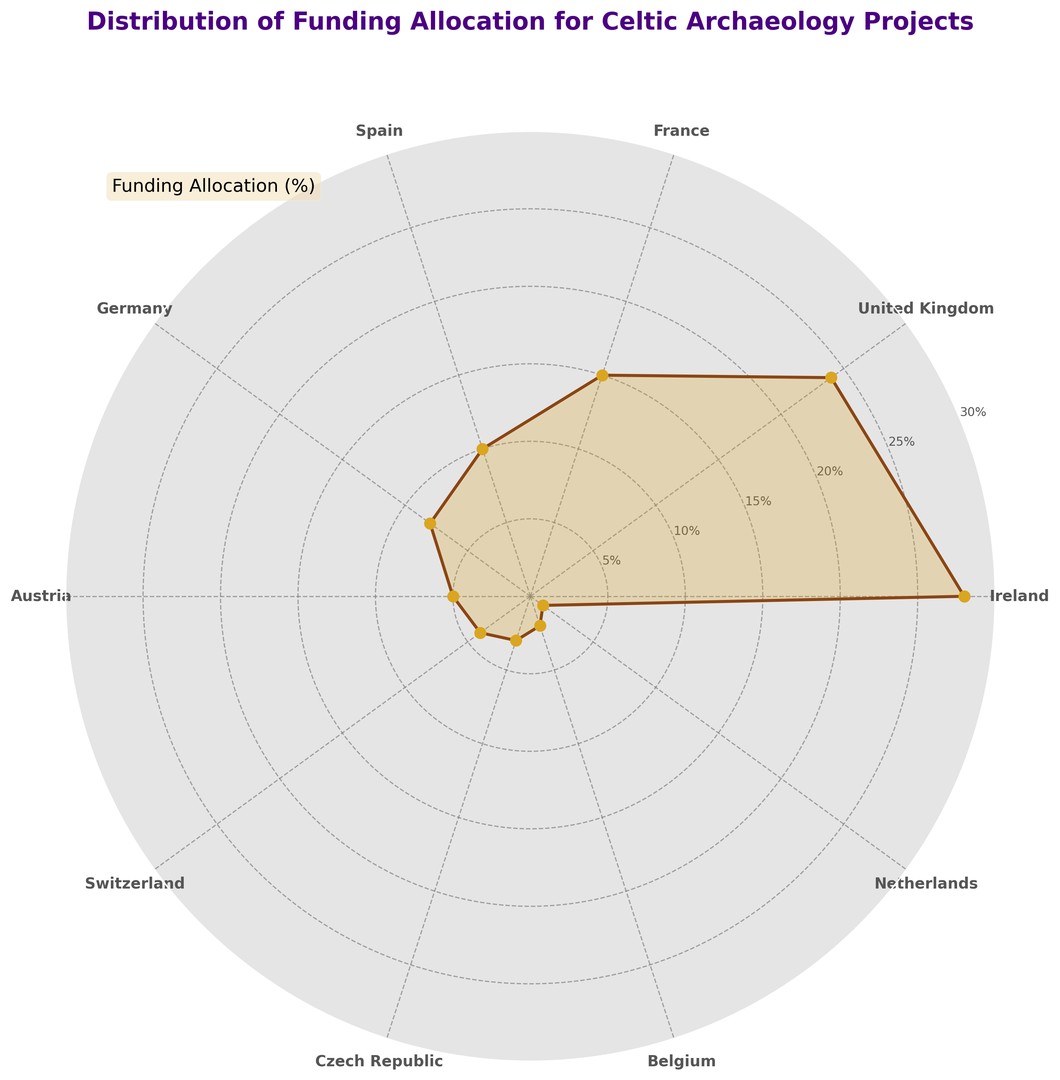What is the funding percentage for the United Kingdom? Identify the segment labeled 'United Kingdom' on the rose chart and read the associated funding percentage.
Answer: 24% Which country has the highest funding allocation? Observe which segment has the greatest extent from the center of the chart. The segment for 'Ireland' reaches the outermost point, indicating the highest funding allocation.
Answer: Ireland Which two countries combined account for more than half of the total funding allocation? Calculate the combined funding of the top countries. Ireland accounts for 28%, and the United Kingdom accounts for 24%, totaling 52%, which is more than half.
Answer: Ireland and United Kingdom Rank the top three countries by funding allocation. Identify the three largest segments in the rose chart by their extent. The segments belong to Ireland (28%), United Kingdom (24%), and France (15%).
Answer: Ireland, United Kingdom, France What is the difference in funding allocation between Spain and Germany? Observe the segments for Spain (10%) and Germany (8%), then calculate the difference: 10% - 8% = 2%.
Answer: 2% How many countries have a funding allocation of less than 5%? Identify the segments less than 5%. These are for Switzerland (4%), Czech Republic (3%), Belgium (2%), and Netherlands (1%). There are 4 such countries.
Answer: 4 Which country has the smallest funding allocation? Observe the segment with the smallest extent from the center. The segment for 'Netherlands' has the smallest extent, indicating 1%.
Answer: Netherlands Is total funding for Germany and Austria greater than for France? Add the segments for Germany (8%) and Austria (5%) yielding 13%. Compare it to France's 15%. Since 13% < 15%, it is not greater.
Answer: No What is the total funding percentage for all countries in the rose chart? The sum of all funding percentages: 28 + 24 + 15 + 10 + 8 + 5 + 4 + 3 + 2 + 1 = 100%.
Answer: 100% Which country allocated 5% funding for Celtic archaeology projects? Identify the segment labeled 'Austria' and read its associated funding percentage.
Answer: Austria 